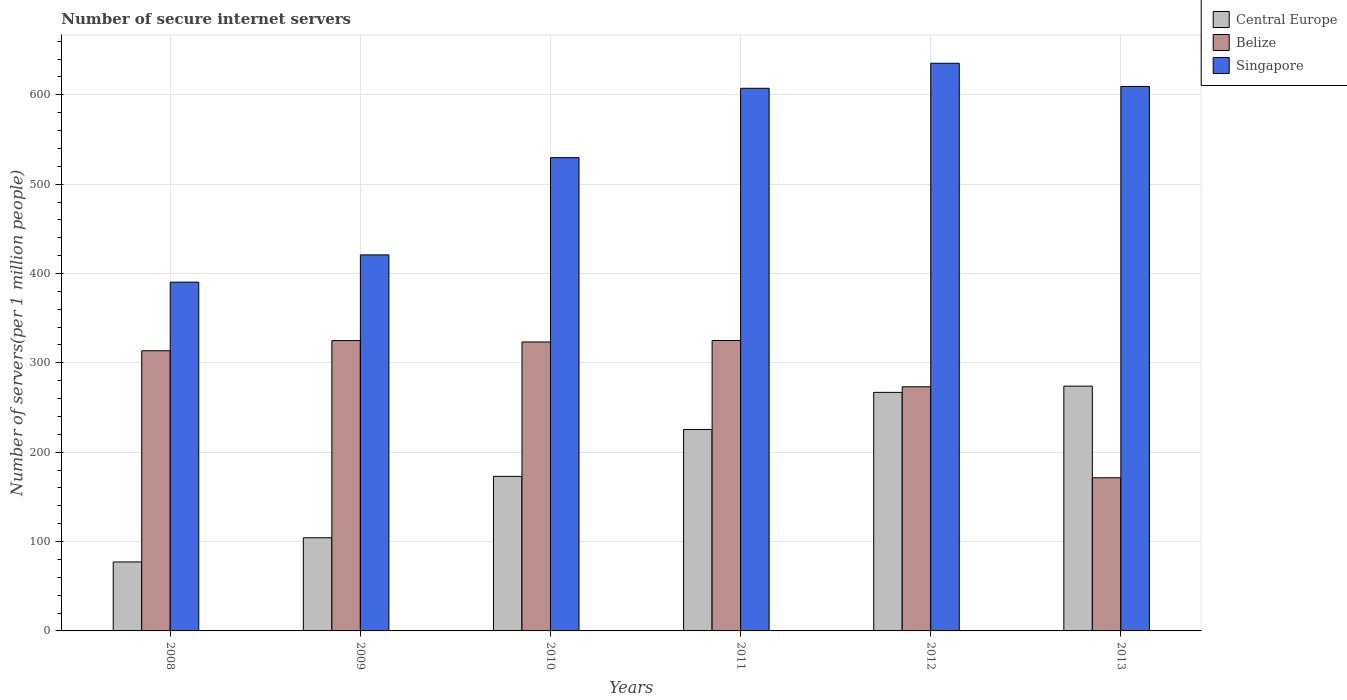How many groups of bars are there?
Make the answer very short. 6. What is the label of the 1st group of bars from the left?
Your response must be concise. 2008. What is the number of secure internet servers in Central Europe in 2011?
Give a very brief answer. 225.45. Across all years, what is the maximum number of secure internet servers in Central Europe?
Keep it short and to the point. 273.97. Across all years, what is the minimum number of secure internet servers in Belize?
Your answer should be very brief. 171.42. In which year was the number of secure internet servers in Belize maximum?
Your response must be concise. 2011. What is the total number of secure internet servers in Central Europe in the graph?
Your answer should be compact. 1120.83. What is the difference between the number of secure internet servers in Singapore in 2008 and that in 2012?
Make the answer very short. -244.97. What is the difference between the number of secure internet servers in Central Europe in 2011 and the number of secure internet servers in Singapore in 2008?
Offer a terse response. -164.89. What is the average number of secure internet servers in Singapore per year?
Make the answer very short. 532.13. In the year 2010, what is the difference between the number of secure internet servers in Singapore and number of secure internet servers in Central Europe?
Provide a succinct answer. 356.7. In how many years, is the number of secure internet servers in Central Europe greater than 640?
Keep it short and to the point. 0. What is the ratio of the number of secure internet servers in Singapore in 2009 to that in 2012?
Your answer should be very brief. 0.66. Is the difference between the number of secure internet servers in Singapore in 2008 and 2011 greater than the difference between the number of secure internet servers in Central Europe in 2008 and 2011?
Offer a very short reply. No. What is the difference between the highest and the second highest number of secure internet servers in Central Europe?
Make the answer very short. 6.98. What is the difference between the highest and the lowest number of secure internet servers in Singapore?
Your answer should be compact. 244.97. What does the 1st bar from the left in 2009 represents?
Offer a very short reply. Central Europe. What does the 1st bar from the right in 2008 represents?
Ensure brevity in your answer.  Singapore. Is it the case that in every year, the sum of the number of secure internet servers in Singapore and number of secure internet servers in Belize is greater than the number of secure internet servers in Central Europe?
Make the answer very short. Yes. How many bars are there?
Your answer should be very brief. 18. How many years are there in the graph?
Your answer should be compact. 6. Does the graph contain any zero values?
Your answer should be compact. No. How many legend labels are there?
Offer a very short reply. 3. What is the title of the graph?
Offer a very short reply. Number of secure internet servers. Does "St. Kitts and Nevis" appear as one of the legend labels in the graph?
Offer a terse response. No. What is the label or title of the Y-axis?
Make the answer very short. Number of servers(per 1 million people). What is the Number of servers(per 1 million people) of Central Europe in 2008?
Make the answer very short. 77.19. What is the Number of servers(per 1 million people) of Belize in 2008?
Offer a very short reply. 313.56. What is the Number of servers(per 1 million people) of Singapore in 2008?
Make the answer very short. 390.34. What is the Number of servers(per 1 million people) in Central Europe in 2009?
Offer a very short reply. 104.27. What is the Number of servers(per 1 million people) of Belize in 2009?
Offer a terse response. 324.92. What is the Number of servers(per 1 million people) in Singapore in 2009?
Keep it short and to the point. 420.84. What is the Number of servers(per 1 million people) in Central Europe in 2010?
Ensure brevity in your answer.  172.97. What is the Number of servers(per 1 million people) of Belize in 2010?
Your answer should be very brief. 323.37. What is the Number of servers(per 1 million people) in Singapore in 2010?
Your response must be concise. 529.67. What is the Number of servers(per 1 million people) of Central Europe in 2011?
Your answer should be very brief. 225.45. What is the Number of servers(per 1 million people) in Belize in 2011?
Provide a succinct answer. 325.04. What is the Number of servers(per 1 million people) in Singapore in 2011?
Keep it short and to the point. 607.29. What is the Number of servers(per 1 million people) in Central Europe in 2012?
Give a very brief answer. 266.98. What is the Number of servers(per 1 million people) of Belize in 2012?
Give a very brief answer. 273.23. What is the Number of servers(per 1 million people) in Singapore in 2012?
Keep it short and to the point. 635.31. What is the Number of servers(per 1 million people) of Central Europe in 2013?
Provide a short and direct response. 273.97. What is the Number of servers(per 1 million people) of Belize in 2013?
Offer a very short reply. 171.42. What is the Number of servers(per 1 million people) in Singapore in 2013?
Give a very brief answer. 609.35. Across all years, what is the maximum Number of servers(per 1 million people) of Central Europe?
Keep it short and to the point. 273.97. Across all years, what is the maximum Number of servers(per 1 million people) in Belize?
Make the answer very short. 325.04. Across all years, what is the maximum Number of servers(per 1 million people) in Singapore?
Keep it short and to the point. 635.31. Across all years, what is the minimum Number of servers(per 1 million people) in Central Europe?
Your answer should be very brief. 77.19. Across all years, what is the minimum Number of servers(per 1 million people) in Belize?
Provide a short and direct response. 171.42. Across all years, what is the minimum Number of servers(per 1 million people) of Singapore?
Make the answer very short. 390.34. What is the total Number of servers(per 1 million people) of Central Europe in the graph?
Give a very brief answer. 1120.83. What is the total Number of servers(per 1 million people) in Belize in the graph?
Make the answer very short. 1731.54. What is the total Number of servers(per 1 million people) of Singapore in the graph?
Provide a short and direct response. 3192.8. What is the difference between the Number of servers(per 1 million people) in Central Europe in 2008 and that in 2009?
Keep it short and to the point. -27.07. What is the difference between the Number of servers(per 1 million people) of Belize in 2008 and that in 2009?
Give a very brief answer. -11.36. What is the difference between the Number of servers(per 1 million people) of Singapore in 2008 and that in 2009?
Give a very brief answer. -30.51. What is the difference between the Number of servers(per 1 million people) in Central Europe in 2008 and that in 2010?
Provide a succinct answer. -95.78. What is the difference between the Number of servers(per 1 million people) of Belize in 2008 and that in 2010?
Offer a very short reply. -9.82. What is the difference between the Number of servers(per 1 million people) in Singapore in 2008 and that in 2010?
Keep it short and to the point. -139.34. What is the difference between the Number of servers(per 1 million people) in Central Europe in 2008 and that in 2011?
Offer a terse response. -148.26. What is the difference between the Number of servers(per 1 million people) of Belize in 2008 and that in 2011?
Give a very brief answer. -11.48. What is the difference between the Number of servers(per 1 million people) of Singapore in 2008 and that in 2011?
Give a very brief answer. -216.95. What is the difference between the Number of servers(per 1 million people) in Central Europe in 2008 and that in 2012?
Give a very brief answer. -189.79. What is the difference between the Number of servers(per 1 million people) of Belize in 2008 and that in 2012?
Make the answer very short. 40.32. What is the difference between the Number of servers(per 1 million people) in Singapore in 2008 and that in 2012?
Keep it short and to the point. -244.97. What is the difference between the Number of servers(per 1 million people) of Central Europe in 2008 and that in 2013?
Your answer should be very brief. -196.77. What is the difference between the Number of servers(per 1 million people) of Belize in 2008 and that in 2013?
Your answer should be compact. 142.14. What is the difference between the Number of servers(per 1 million people) in Singapore in 2008 and that in 2013?
Offer a very short reply. -219.01. What is the difference between the Number of servers(per 1 million people) of Central Europe in 2009 and that in 2010?
Ensure brevity in your answer.  -68.7. What is the difference between the Number of servers(per 1 million people) in Belize in 2009 and that in 2010?
Your response must be concise. 1.54. What is the difference between the Number of servers(per 1 million people) of Singapore in 2009 and that in 2010?
Provide a succinct answer. -108.83. What is the difference between the Number of servers(per 1 million people) in Central Europe in 2009 and that in 2011?
Ensure brevity in your answer.  -121.18. What is the difference between the Number of servers(per 1 million people) of Belize in 2009 and that in 2011?
Provide a succinct answer. -0.12. What is the difference between the Number of servers(per 1 million people) of Singapore in 2009 and that in 2011?
Make the answer very short. -186.44. What is the difference between the Number of servers(per 1 million people) in Central Europe in 2009 and that in 2012?
Ensure brevity in your answer.  -162.72. What is the difference between the Number of servers(per 1 million people) of Belize in 2009 and that in 2012?
Offer a very short reply. 51.68. What is the difference between the Number of servers(per 1 million people) of Singapore in 2009 and that in 2012?
Your response must be concise. -214.46. What is the difference between the Number of servers(per 1 million people) of Central Europe in 2009 and that in 2013?
Your response must be concise. -169.7. What is the difference between the Number of servers(per 1 million people) of Belize in 2009 and that in 2013?
Your answer should be compact. 153.5. What is the difference between the Number of servers(per 1 million people) of Singapore in 2009 and that in 2013?
Your answer should be very brief. -188.51. What is the difference between the Number of servers(per 1 million people) of Central Europe in 2010 and that in 2011?
Your answer should be very brief. -52.48. What is the difference between the Number of servers(per 1 million people) of Belize in 2010 and that in 2011?
Ensure brevity in your answer.  -1.66. What is the difference between the Number of servers(per 1 million people) in Singapore in 2010 and that in 2011?
Ensure brevity in your answer.  -77.61. What is the difference between the Number of servers(per 1 million people) of Central Europe in 2010 and that in 2012?
Keep it short and to the point. -94.01. What is the difference between the Number of servers(per 1 million people) in Belize in 2010 and that in 2012?
Your response must be concise. 50.14. What is the difference between the Number of servers(per 1 million people) of Singapore in 2010 and that in 2012?
Provide a succinct answer. -105.63. What is the difference between the Number of servers(per 1 million people) of Central Europe in 2010 and that in 2013?
Offer a terse response. -101. What is the difference between the Number of servers(per 1 million people) in Belize in 2010 and that in 2013?
Give a very brief answer. 151.96. What is the difference between the Number of servers(per 1 million people) in Singapore in 2010 and that in 2013?
Offer a terse response. -79.67. What is the difference between the Number of servers(per 1 million people) in Central Europe in 2011 and that in 2012?
Keep it short and to the point. -41.53. What is the difference between the Number of servers(per 1 million people) in Belize in 2011 and that in 2012?
Offer a very short reply. 51.8. What is the difference between the Number of servers(per 1 million people) of Singapore in 2011 and that in 2012?
Offer a terse response. -28.02. What is the difference between the Number of servers(per 1 million people) in Central Europe in 2011 and that in 2013?
Provide a short and direct response. -48.52. What is the difference between the Number of servers(per 1 million people) in Belize in 2011 and that in 2013?
Make the answer very short. 153.62. What is the difference between the Number of servers(per 1 million people) of Singapore in 2011 and that in 2013?
Your answer should be very brief. -2.06. What is the difference between the Number of servers(per 1 million people) in Central Europe in 2012 and that in 2013?
Offer a terse response. -6.98. What is the difference between the Number of servers(per 1 million people) of Belize in 2012 and that in 2013?
Offer a terse response. 101.82. What is the difference between the Number of servers(per 1 million people) in Singapore in 2012 and that in 2013?
Offer a very short reply. 25.96. What is the difference between the Number of servers(per 1 million people) in Central Europe in 2008 and the Number of servers(per 1 million people) in Belize in 2009?
Ensure brevity in your answer.  -247.73. What is the difference between the Number of servers(per 1 million people) of Central Europe in 2008 and the Number of servers(per 1 million people) of Singapore in 2009?
Make the answer very short. -343.65. What is the difference between the Number of servers(per 1 million people) in Belize in 2008 and the Number of servers(per 1 million people) in Singapore in 2009?
Provide a short and direct response. -107.29. What is the difference between the Number of servers(per 1 million people) in Central Europe in 2008 and the Number of servers(per 1 million people) in Belize in 2010?
Provide a short and direct response. -246.18. What is the difference between the Number of servers(per 1 million people) in Central Europe in 2008 and the Number of servers(per 1 million people) in Singapore in 2010?
Make the answer very short. -452.48. What is the difference between the Number of servers(per 1 million people) of Belize in 2008 and the Number of servers(per 1 million people) of Singapore in 2010?
Give a very brief answer. -216.12. What is the difference between the Number of servers(per 1 million people) of Central Europe in 2008 and the Number of servers(per 1 million people) of Belize in 2011?
Offer a terse response. -247.84. What is the difference between the Number of servers(per 1 million people) in Central Europe in 2008 and the Number of servers(per 1 million people) in Singapore in 2011?
Your answer should be very brief. -530.1. What is the difference between the Number of servers(per 1 million people) in Belize in 2008 and the Number of servers(per 1 million people) in Singapore in 2011?
Offer a very short reply. -293.73. What is the difference between the Number of servers(per 1 million people) in Central Europe in 2008 and the Number of servers(per 1 million people) in Belize in 2012?
Ensure brevity in your answer.  -196.04. What is the difference between the Number of servers(per 1 million people) of Central Europe in 2008 and the Number of servers(per 1 million people) of Singapore in 2012?
Provide a succinct answer. -558.11. What is the difference between the Number of servers(per 1 million people) of Belize in 2008 and the Number of servers(per 1 million people) of Singapore in 2012?
Offer a very short reply. -321.75. What is the difference between the Number of servers(per 1 million people) of Central Europe in 2008 and the Number of servers(per 1 million people) of Belize in 2013?
Your response must be concise. -94.22. What is the difference between the Number of servers(per 1 million people) of Central Europe in 2008 and the Number of servers(per 1 million people) of Singapore in 2013?
Provide a succinct answer. -532.16. What is the difference between the Number of servers(per 1 million people) of Belize in 2008 and the Number of servers(per 1 million people) of Singapore in 2013?
Your answer should be very brief. -295.79. What is the difference between the Number of servers(per 1 million people) in Central Europe in 2009 and the Number of servers(per 1 million people) in Belize in 2010?
Ensure brevity in your answer.  -219.11. What is the difference between the Number of servers(per 1 million people) in Central Europe in 2009 and the Number of servers(per 1 million people) in Singapore in 2010?
Offer a very short reply. -425.41. What is the difference between the Number of servers(per 1 million people) in Belize in 2009 and the Number of servers(per 1 million people) in Singapore in 2010?
Your response must be concise. -204.76. What is the difference between the Number of servers(per 1 million people) in Central Europe in 2009 and the Number of servers(per 1 million people) in Belize in 2011?
Make the answer very short. -220.77. What is the difference between the Number of servers(per 1 million people) in Central Europe in 2009 and the Number of servers(per 1 million people) in Singapore in 2011?
Make the answer very short. -503.02. What is the difference between the Number of servers(per 1 million people) of Belize in 2009 and the Number of servers(per 1 million people) of Singapore in 2011?
Your response must be concise. -282.37. What is the difference between the Number of servers(per 1 million people) of Central Europe in 2009 and the Number of servers(per 1 million people) of Belize in 2012?
Ensure brevity in your answer.  -168.97. What is the difference between the Number of servers(per 1 million people) of Central Europe in 2009 and the Number of servers(per 1 million people) of Singapore in 2012?
Keep it short and to the point. -531.04. What is the difference between the Number of servers(per 1 million people) of Belize in 2009 and the Number of servers(per 1 million people) of Singapore in 2012?
Your answer should be compact. -310.39. What is the difference between the Number of servers(per 1 million people) in Central Europe in 2009 and the Number of servers(per 1 million people) in Belize in 2013?
Make the answer very short. -67.15. What is the difference between the Number of servers(per 1 million people) in Central Europe in 2009 and the Number of servers(per 1 million people) in Singapore in 2013?
Ensure brevity in your answer.  -505.08. What is the difference between the Number of servers(per 1 million people) of Belize in 2009 and the Number of servers(per 1 million people) of Singapore in 2013?
Make the answer very short. -284.43. What is the difference between the Number of servers(per 1 million people) of Central Europe in 2010 and the Number of servers(per 1 million people) of Belize in 2011?
Keep it short and to the point. -152.07. What is the difference between the Number of servers(per 1 million people) of Central Europe in 2010 and the Number of servers(per 1 million people) of Singapore in 2011?
Give a very brief answer. -434.32. What is the difference between the Number of servers(per 1 million people) in Belize in 2010 and the Number of servers(per 1 million people) in Singapore in 2011?
Ensure brevity in your answer.  -283.91. What is the difference between the Number of servers(per 1 million people) in Central Europe in 2010 and the Number of servers(per 1 million people) in Belize in 2012?
Your answer should be very brief. -100.26. What is the difference between the Number of servers(per 1 million people) in Central Europe in 2010 and the Number of servers(per 1 million people) in Singapore in 2012?
Your response must be concise. -462.34. What is the difference between the Number of servers(per 1 million people) of Belize in 2010 and the Number of servers(per 1 million people) of Singapore in 2012?
Give a very brief answer. -311.93. What is the difference between the Number of servers(per 1 million people) of Central Europe in 2010 and the Number of servers(per 1 million people) of Belize in 2013?
Provide a short and direct response. 1.56. What is the difference between the Number of servers(per 1 million people) of Central Europe in 2010 and the Number of servers(per 1 million people) of Singapore in 2013?
Ensure brevity in your answer.  -436.38. What is the difference between the Number of servers(per 1 million people) in Belize in 2010 and the Number of servers(per 1 million people) in Singapore in 2013?
Provide a succinct answer. -285.98. What is the difference between the Number of servers(per 1 million people) of Central Europe in 2011 and the Number of servers(per 1 million people) of Belize in 2012?
Keep it short and to the point. -47.78. What is the difference between the Number of servers(per 1 million people) in Central Europe in 2011 and the Number of servers(per 1 million people) in Singapore in 2012?
Provide a short and direct response. -409.86. What is the difference between the Number of servers(per 1 million people) of Belize in 2011 and the Number of servers(per 1 million people) of Singapore in 2012?
Your answer should be very brief. -310.27. What is the difference between the Number of servers(per 1 million people) of Central Europe in 2011 and the Number of servers(per 1 million people) of Belize in 2013?
Offer a terse response. 54.03. What is the difference between the Number of servers(per 1 million people) of Central Europe in 2011 and the Number of servers(per 1 million people) of Singapore in 2013?
Your response must be concise. -383.9. What is the difference between the Number of servers(per 1 million people) in Belize in 2011 and the Number of servers(per 1 million people) in Singapore in 2013?
Keep it short and to the point. -284.31. What is the difference between the Number of servers(per 1 million people) of Central Europe in 2012 and the Number of servers(per 1 million people) of Belize in 2013?
Your response must be concise. 95.57. What is the difference between the Number of servers(per 1 million people) of Central Europe in 2012 and the Number of servers(per 1 million people) of Singapore in 2013?
Keep it short and to the point. -342.37. What is the difference between the Number of servers(per 1 million people) of Belize in 2012 and the Number of servers(per 1 million people) of Singapore in 2013?
Keep it short and to the point. -336.11. What is the average Number of servers(per 1 million people) of Central Europe per year?
Your answer should be very brief. 186.8. What is the average Number of servers(per 1 million people) of Belize per year?
Provide a short and direct response. 288.59. What is the average Number of servers(per 1 million people) of Singapore per year?
Offer a very short reply. 532.13. In the year 2008, what is the difference between the Number of servers(per 1 million people) of Central Europe and Number of servers(per 1 million people) of Belize?
Ensure brevity in your answer.  -236.36. In the year 2008, what is the difference between the Number of servers(per 1 million people) in Central Europe and Number of servers(per 1 million people) in Singapore?
Offer a terse response. -313.15. In the year 2008, what is the difference between the Number of servers(per 1 million people) of Belize and Number of servers(per 1 million people) of Singapore?
Offer a very short reply. -76.78. In the year 2009, what is the difference between the Number of servers(per 1 million people) of Central Europe and Number of servers(per 1 million people) of Belize?
Your response must be concise. -220.65. In the year 2009, what is the difference between the Number of servers(per 1 million people) in Central Europe and Number of servers(per 1 million people) in Singapore?
Your response must be concise. -316.58. In the year 2009, what is the difference between the Number of servers(per 1 million people) of Belize and Number of servers(per 1 million people) of Singapore?
Your response must be concise. -95.93. In the year 2010, what is the difference between the Number of servers(per 1 million people) in Central Europe and Number of servers(per 1 million people) in Belize?
Give a very brief answer. -150.4. In the year 2010, what is the difference between the Number of servers(per 1 million people) of Central Europe and Number of servers(per 1 million people) of Singapore?
Your response must be concise. -356.7. In the year 2010, what is the difference between the Number of servers(per 1 million people) of Belize and Number of servers(per 1 million people) of Singapore?
Give a very brief answer. -206.3. In the year 2011, what is the difference between the Number of servers(per 1 million people) in Central Europe and Number of servers(per 1 million people) in Belize?
Offer a very short reply. -99.59. In the year 2011, what is the difference between the Number of servers(per 1 million people) in Central Europe and Number of servers(per 1 million people) in Singapore?
Provide a short and direct response. -381.84. In the year 2011, what is the difference between the Number of servers(per 1 million people) of Belize and Number of servers(per 1 million people) of Singapore?
Offer a terse response. -282.25. In the year 2012, what is the difference between the Number of servers(per 1 million people) in Central Europe and Number of servers(per 1 million people) in Belize?
Provide a short and direct response. -6.25. In the year 2012, what is the difference between the Number of servers(per 1 million people) in Central Europe and Number of servers(per 1 million people) in Singapore?
Provide a short and direct response. -368.32. In the year 2012, what is the difference between the Number of servers(per 1 million people) of Belize and Number of servers(per 1 million people) of Singapore?
Keep it short and to the point. -362.07. In the year 2013, what is the difference between the Number of servers(per 1 million people) in Central Europe and Number of servers(per 1 million people) in Belize?
Make the answer very short. 102.55. In the year 2013, what is the difference between the Number of servers(per 1 million people) in Central Europe and Number of servers(per 1 million people) in Singapore?
Your answer should be very brief. -335.38. In the year 2013, what is the difference between the Number of servers(per 1 million people) of Belize and Number of servers(per 1 million people) of Singapore?
Your answer should be very brief. -437.93. What is the ratio of the Number of servers(per 1 million people) in Central Europe in 2008 to that in 2009?
Provide a succinct answer. 0.74. What is the ratio of the Number of servers(per 1 million people) of Singapore in 2008 to that in 2009?
Your response must be concise. 0.93. What is the ratio of the Number of servers(per 1 million people) in Central Europe in 2008 to that in 2010?
Your answer should be very brief. 0.45. What is the ratio of the Number of servers(per 1 million people) in Belize in 2008 to that in 2010?
Your answer should be very brief. 0.97. What is the ratio of the Number of servers(per 1 million people) of Singapore in 2008 to that in 2010?
Make the answer very short. 0.74. What is the ratio of the Number of servers(per 1 million people) in Central Europe in 2008 to that in 2011?
Offer a very short reply. 0.34. What is the ratio of the Number of servers(per 1 million people) of Belize in 2008 to that in 2011?
Provide a short and direct response. 0.96. What is the ratio of the Number of servers(per 1 million people) of Singapore in 2008 to that in 2011?
Your answer should be very brief. 0.64. What is the ratio of the Number of servers(per 1 million people) in Central Europe in 2008 to that in 2012?
Keep it short and to the point. 0.29. What is the ratio of the Number of servers(per 1 million people) in Belize in 2008 to that in 2012?
Ensure brevity in your answer.  1.15. What is the ratio of the Number of servers(per 1 million people) in Singapore in 2008 to that in 2012?
Offer a very short reply. 0.61. What is the ratio of the Number of servers(per 1 million people) in Central Europe in 2008 to that in 2013?
Provide a succinct answer. 0.28. What is the ratio of the Number of servers(per 1 million people) of Belize in 2008 to that in 2013?
Offer a very short reply. 1.83. What is the ratio of the Number of servers(per 1 million people) in Singapore in 2008 to that in 2013?
Ensure brevity in your answer.  0.64. What is the ratio of the Number of servers(per 1 million people) in Central Europe in 2009 to that in 2010?
Your answer should be very brief. 0.6. What is the ratio of the Number of servers(per 1 million people) of Singapore in 2009 to that in 2010?
Ensure brevity in your answer.  0.79. What is the ratio of the Number of servers(per 1 million people) of Central Europe in 2009 to that in 2011?
Ensure brevity in your answer.  0.46. What is the ratio of the Number of servers(per 1 million people) in Belize in 2009 to that in 2011?
Provide a succinct answer. 1. What is the ratio of the Number of servers(per 1 million people) in Singapore in 2009 to that in 2011?
Make the answer very short. 0.69. What is the ratio of the Number of servers(per 1 million people) of Central Europe in 2009 to that in 2012?
Offer a very short reply. 0.39. What is the ratio of the Number of servers(per 1 million people) in Belize in 2009 to that in 2012?
Provide a succinct answer. 1.19. What is the ratio of the Number of servers(per 1 million people) of Singapore in 2009 to that in 2012?
Offer a very short reply. 0.66. What is the ratio of the Number of servers(per 1 million people) in Central Europe in 2009 to that in 2013?
Offer a terse response. 0.38. What is the ratio of the Number of servers(per 1 million people) of Belize in 2009 to that in 2013?
Keep it short and to the point. 1.9. What is the ratio of the Number of servers(per 1 million people) in Singapore in 2009 to that in 2013?
Provide a short and direct response. 0.69. What is the ratio of the Number of servers(per 1 million people) in Central Europe in 2010 to that in 2011?
Ensure brevity in your answer.  0.77. What is the ratio of the Number of servers(per 1 million people) in Singapore in 2010 to that in 2011?
Your response must be concise. 0.87. What is the ratio of the Number of servers(per 1 million people) of Central Europe in 2010 to that in 2012?
Provide a succinct answer. 0.65. What is the ratio of the Number of servers(per 1 million people) in Belize in 2010 to that in 2012?
Your answer should be compact. 1.18. What is the ratio of the Number of servers(per 1 million people) in Singapore in 2010 to that in 2012?
Give a very brief answer. 0.83. What is the ratio of the Number of servers(per 1 million people) of Central Europe in 2010 to that in 2013?
Give a very brief answer. 0.63. What is the ratio of the Number of servers(per 1 million people) in Belize in 2010 to that in 2013?
Your answer should be compact. 1.89. What is the ratio of the Number of servers(per 1 million people) in Singapore in 2010 to that in 2013?
Keep it short and to the point. 0.87. What is the ratio of the Number of servers(per 1 million people) of Central Europe in 2011 to that in 2012?
Provide a short and direct response. 0.84. What is the ratio of the Number of servers(per 1 million people) of Belize in 2011 to that in 2012?
Your answer should be compact. 1.19. What is the ratio of the Number of servers(per 1 million people) in Singapore in 2011 to that in 2012?
Make the answer very short. 0.96. What is the ratio of the Number of servers(per 1 million people) of Central Europe in 2011 to that in 2013?
Offer a very short reply. 0.82. What is the ratio of the Number of servers(per 1 million people) in Belize in 2011 to that in 2013?
Make the answer very short. 1.9. What is the ratio of the Number of servers(per 1 million people) of Central Europe in 2012 to that in 2013?
Ensure brevity in your answer.  0.97. What is the ratio of the Number of servers(per 1 million people) of Belize in 2012 to that in 2013?
Keep it short and to the point. 1.59. What is the ratio of the Number of servers(per 1 million people) of Singapore in 2012 to that in 2013?
Provide a short and direct response. 1.04. What is the difference between the highest and the second highest Number of servers(per 1 million people) of Central Europe?
Your answer should be compact. 6.98. What is the difference between the highest and the second highest Number of servers(per 1 million people) in Belize?
Your response must be concise. 0.12. What is the difference between the highest and the second highest Number of servers(per 1 million people) in Singapore?
Provide a short and direct response. 25.96. What is the difference between the highest and the lowest Number of servers(per 1 million people) of Central Europe?
Your answer should be very brief. 196.77. What is the difference between the highest and the lowest Number of servers(per 1 million people) in Belize?
Your answer should be compact. 153.62. What is the difference between the highest and the lowest Number of servers(per 1 million people) in Singapore?
Your answer should be compact. 244.97. 